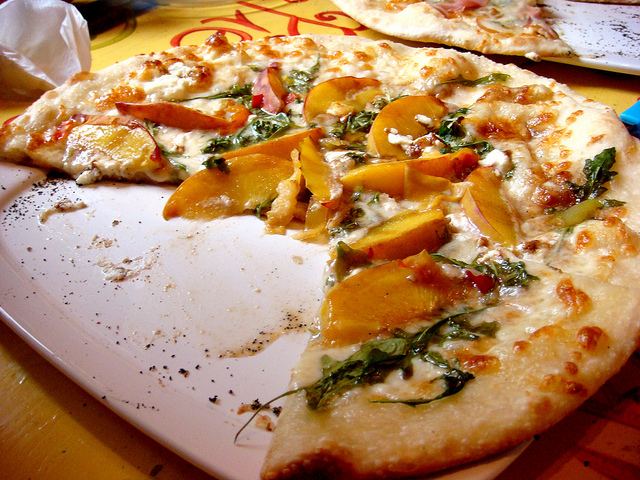How many dining tables are there? 1 